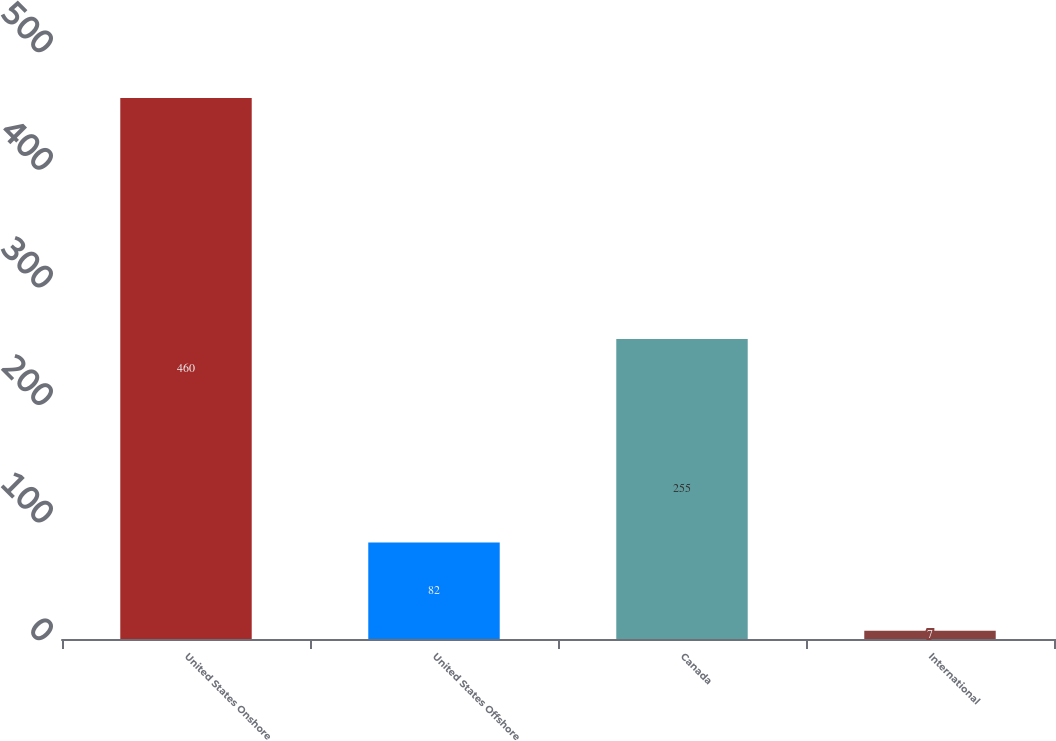Convert chart. <chart><loc_0><loc_0><loc_500><loc_500><bar_chart><fcel>United States Onshore<fcel>United States Offshore<fcel>Canada<fcel>International<nl><fcel>460<fcel>82<fcel>255<fcel>7<nl></chart> 